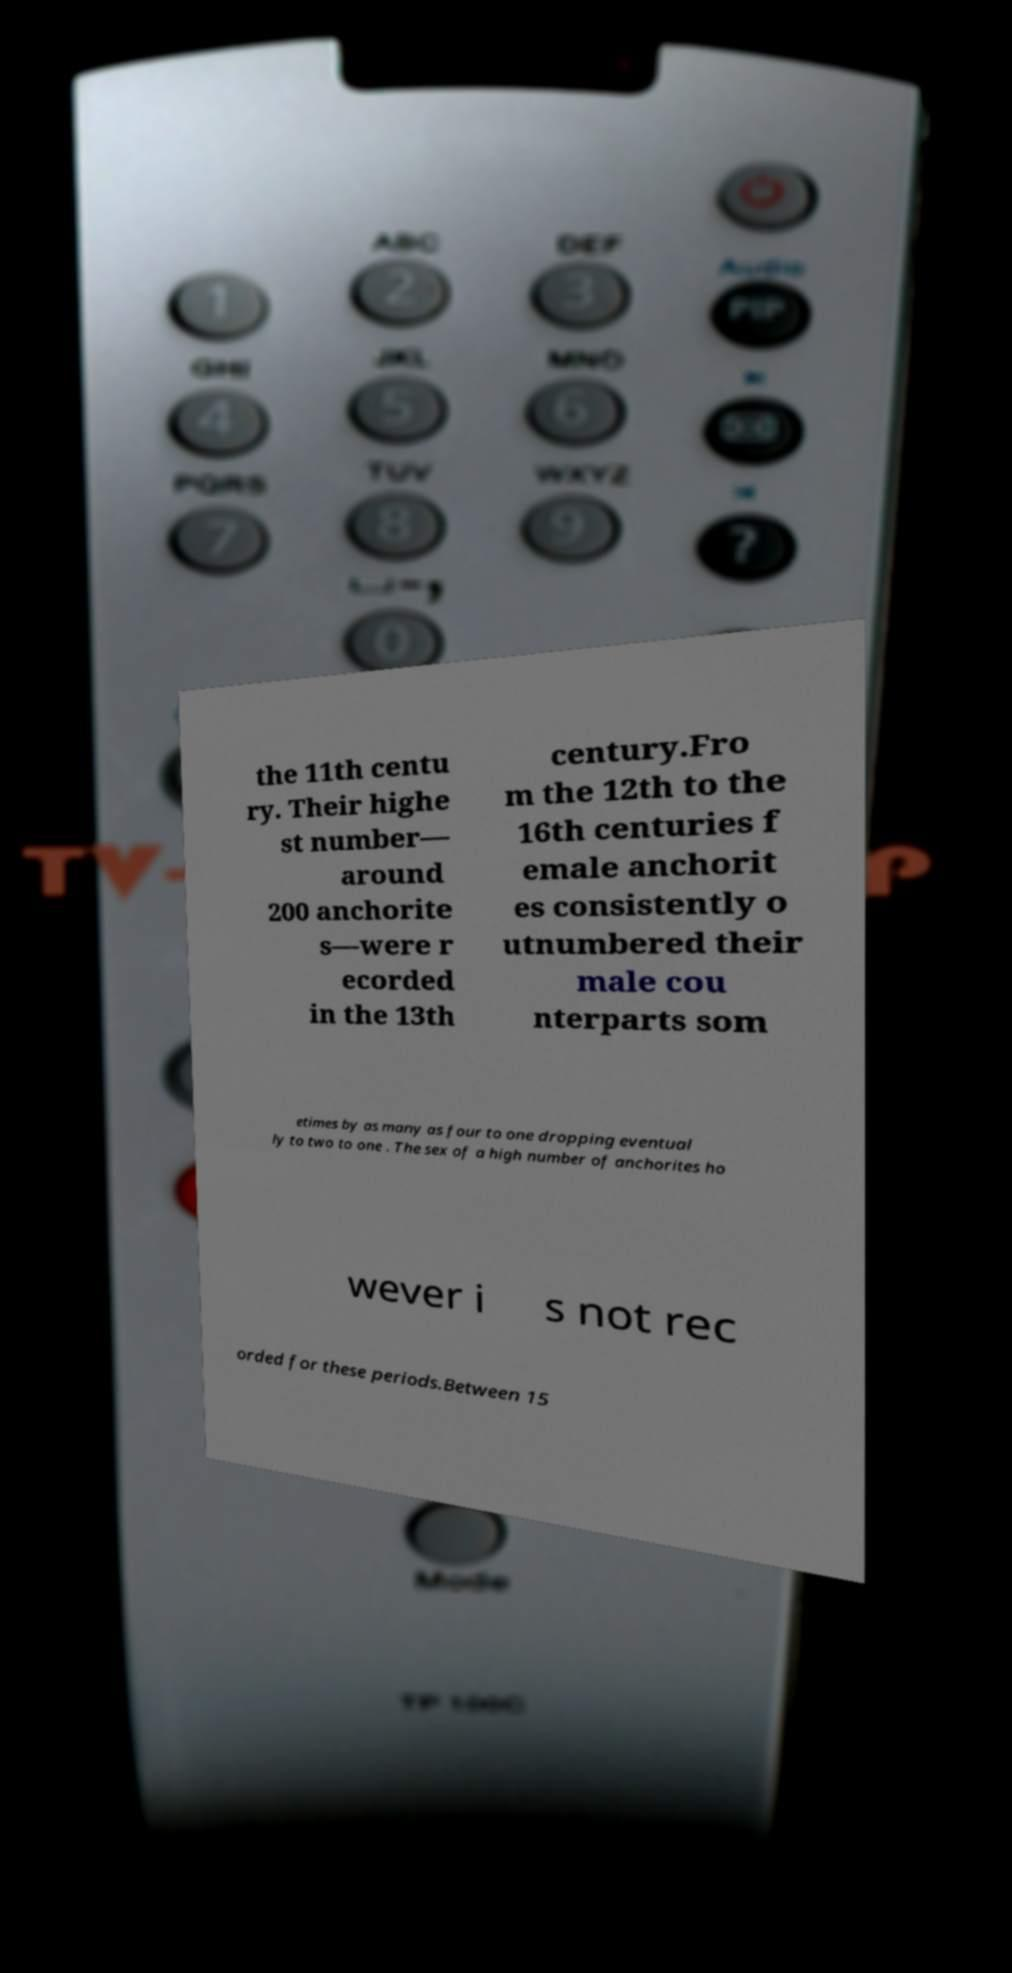There's text embedded in this image that I need extracted. Can you transcribe it verbatim? the 11th centu ry. Their highe st number— around 200 anchorite s—were r ecorded in the 13th century.Fro m the 12th to the 16th centuries f emale anchorit es consistently o utnumbered their male cou nterparts som etimes by as many as four to one dropping eventual ly to two to one . The sex of a high number of anchorites ho wever i s not rec orded for these periods.Between 15 